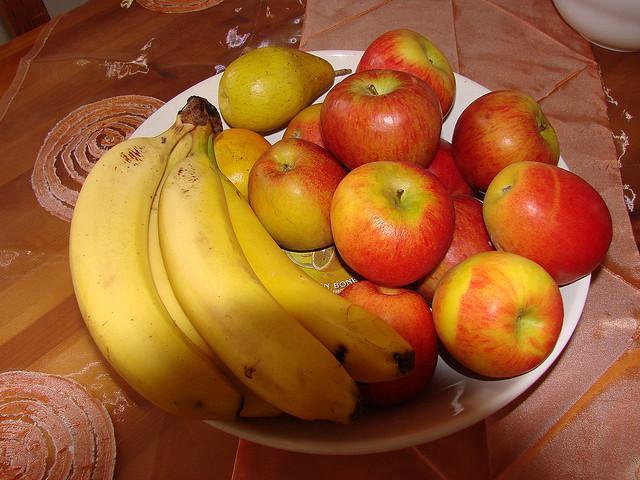Does the image validate the caption "The apple is at the left side of the banana."?
Answer yes or no. No. 